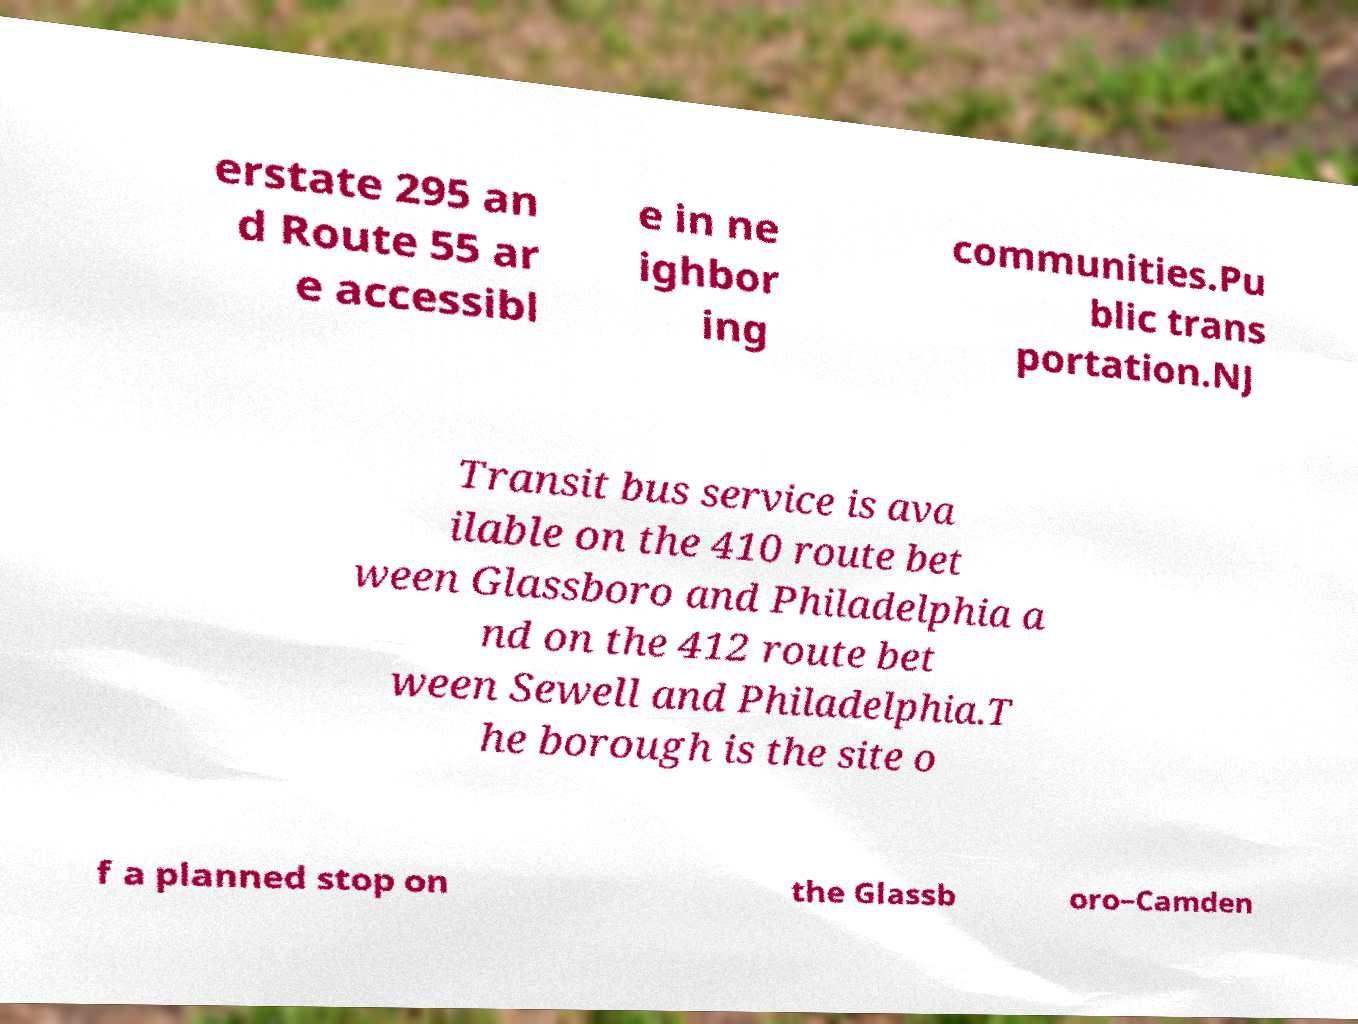For documentation purposes, I need the text within this image transcribed. Could you provide that? erstate 295 an d Route 55 ar e accessibl e in ne ighbor ing communities.Pu blic trans portation.NJ Transit bus service is ava ilable on the 410 route bet ween Glassboro and Philadelphia a nd on the 412 route bet ween Sewell and Philadelphia.T he borough is the site o f a planned stop on the Glassb oro–Camden 